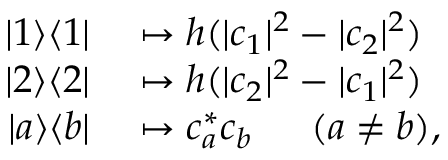Convert formula to latex. <formula><loc_0><loc_0><loc_500><loc_500>\begin{array} { r l } { | 1 \rangle \langle 1 | } & \mapsto h ( | c _ { 1 } | ^ { 2 } - | c _ { 2 } | ^ { 2 } ) } \\ { | 2 \rangle \langle 2 | } & \mapsto h ( | c _ { 2 } | ^ { 2 } - | c _ { 1 } | ^ { 2 } ) } \\ { | a \rangle \langle b | } & \mapsto c _ { a } ^ { * } c _ { b } \quad \ \, ( a \neq b ) , } \end{array}</formula> 